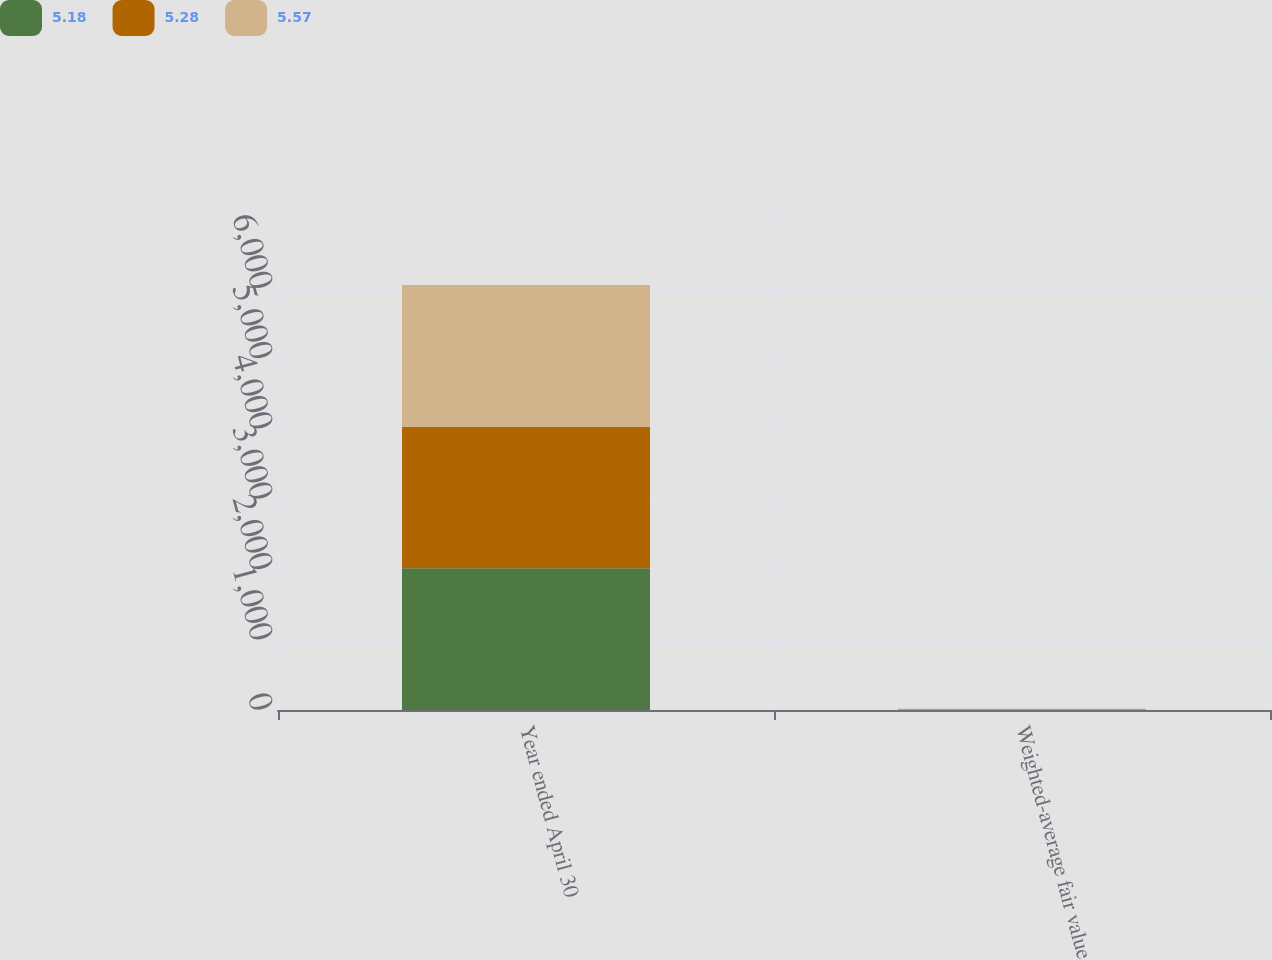<chart> <loc_0><loc_0><loc_500><loc_500><stacked_bar_chart><ecel><fcel>Year ended April 30<fcel>Weighted-average fair value<nl><fcel>5.18<fcel>2016<fcel>5.28<nl><fcel>5.28<fcel>2015<fcel>5.18<nl><fcel>5.57<fcel>2014<fcel>5.57<nl></chart> 